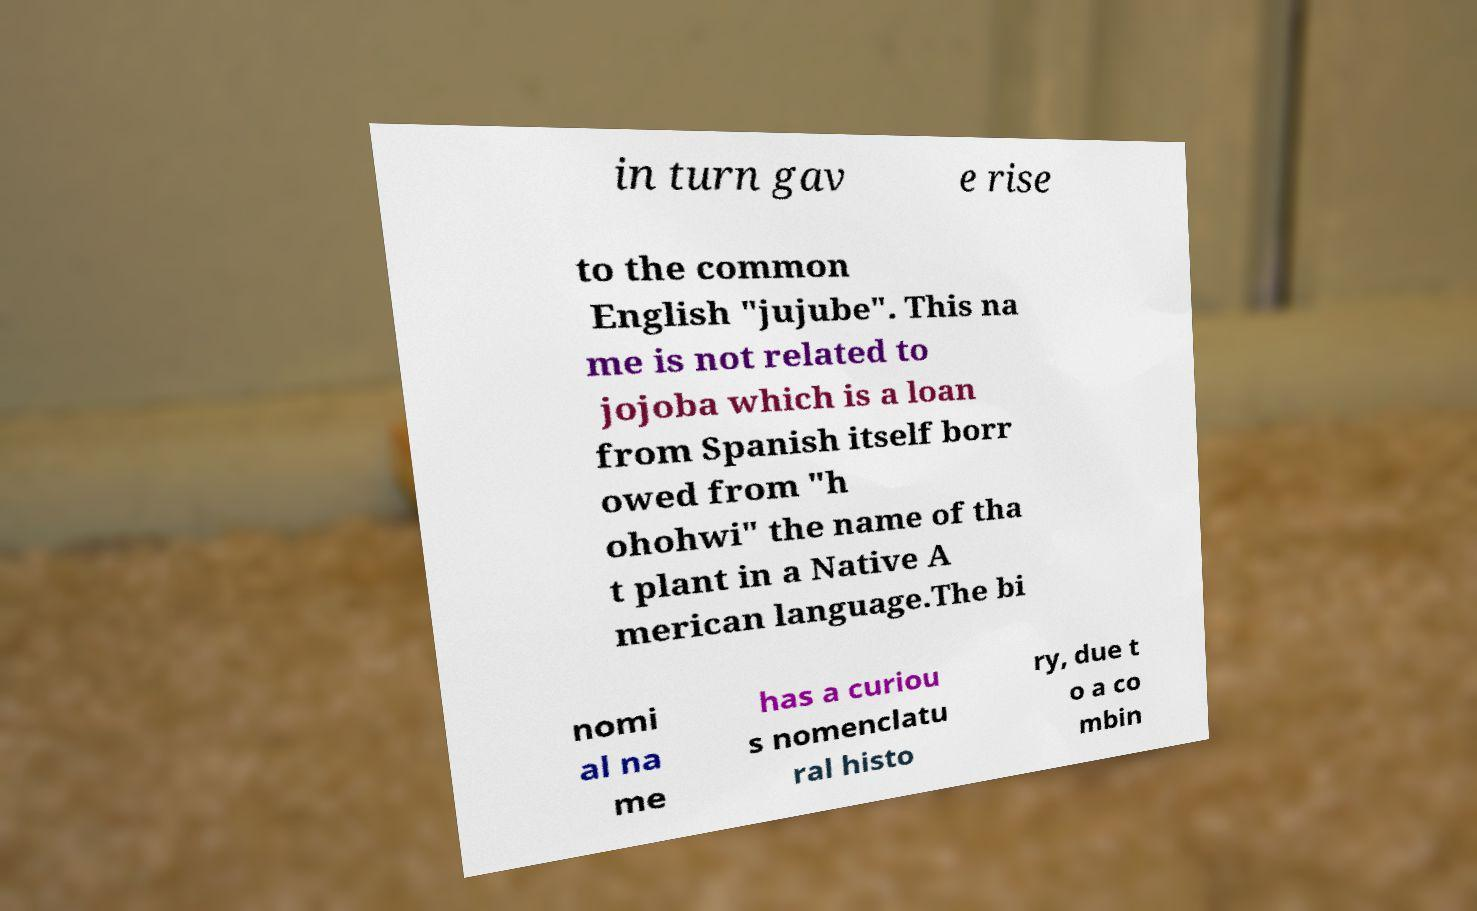I need the written content from this picture converted into text. Can you do that? in turn gav e rise to the common English "jujube". This na me is not related to jojoba which is a loan from Spanish itself borr owed from "h ohohwi" the name of tha t plant in a Native A merican language.The bi nomi al na me has a curiou s nomenclatu ral histo ry, due t o a co mbin 